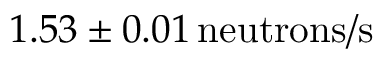<formula> <loc_0><loc_0><loc_500><loc_500>1 . 5 3 \pm 0 . 0 1 \, n e u t r o n s / s</formula> 